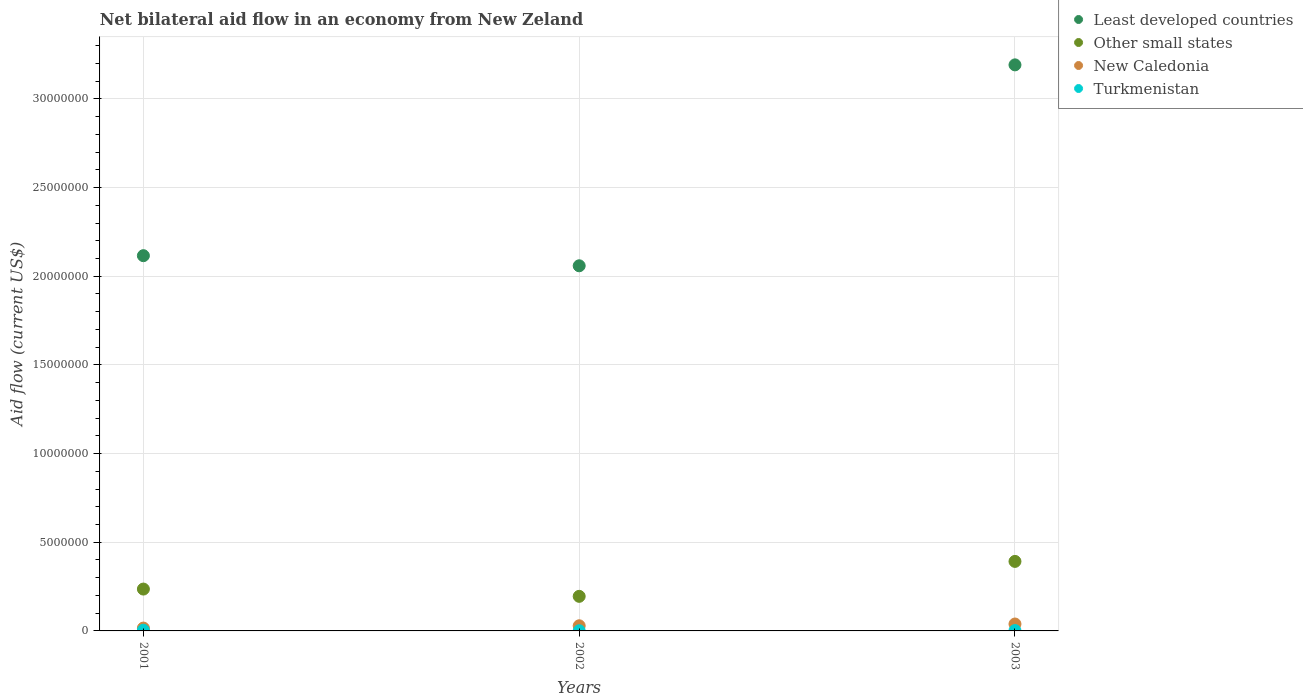How many different coloured dotlines are there?
Offer a terse response. 4. Across all years, what is the maximum net bilateral aid flow in Other small states?
Give a very brief answer. 3.92e+06. Across all years, what is the minimum net bilateral aid flow in Least developed countries?
Provide a succinct answer. 2.06e+07. In which year was the net bilateral aid flow in Least developed countries maximum?
Your answer should be very brief. 2003. What is the difference between the net bilateral aid flow in Turkmenistan in 2002 and that in 2003?
Your response must be concise. -10000. What is the difference between the net bilateral aid flow in Other small states in 2002 and the net bilateral aid flow in Turkmenistan in 2001?
Offer a terse response. 1.91e+06. What is the average net bilateral aid flow in Turkmenistan per year?
Provide a succinct answer. 2.33e+04. What is the ratio of the net bilateral aid flow in Other small states in 2002 to that in 2003?
Offer a very short reply. 0.5. What is the difference between the highest and the second highest net bilateral aid flow in Turkmenistan?
Your response must be concise. 2.00e+04. What is the difference between the highest and the lowest net bilateral aid flow in Other small states?
Make the answer very short. 1.97e+06. Is the sum of the net bilateral aid flow in Least developed countries in 2001 and 2002 greater than the maximum net bilateral aid flow in New Caledonia across all years?
Offer a terse response. Yes. Is the net bilateral aid flow in New Caledonia strictly greater than the net bilateral aid flow in Least developed countries over the years?
Provide a succinct answer. No. Are the values on the major ticks of Y-axis written in scientific E-notation?
Give a very brief answer. No. What is the title of the graph?
Your answer should be very brief. Net bilateral aid flow in an economy from New Zeland. Does "Burkina Faso" appear as one of the legend labels in the graph?
Your response must be concise. No. What is the label or title of the Y-axis?
Your answer should be very brief. Aid flow (current US$). What is the Aid flow (current US$) of Least developed countries in 2001?
Your answer should be compact. 2.12e+07. What is the Aid flow (current US$) in Other small states in 2001?
Provide a succinct answer. 2.36e+06. What is the Aid flow (current US$) of Least developed countries in 2002?
Keep it short and to the point. 2.06e+07. What is the Aid flow (current US$) in Other small states in 2002?
Provide a short and direct response. 1.95e+06. What is the Aid flow (current US$) of Turkmenistan in 2002?
Provide a succinct answer. 10000. What is the Aid flow (current US$) in Least developed countries in 2003?
Offer a terse response. 3.19e+07. What is the Aid flow (current US$) of Other small states in 2003?
Ensure brevity in your answer.  3.92e+06. What is the Aid flow (current US$) of New Caledonia in 2003?
Offer a terse response. 3.90e+05. What is the Aid flow (current US$) of Turkmenistan in 2003?
Offer a very short reply. 2.00e+04. Across all years, what is the maximum Aid flow (current US$) in Least developed countries?
Offer a very short reply. 3.19e+07. Across all years, what is the maximum Aid flow (current US$) of Other small states?
Your answer should be very brief. 3.92e+06. Across all years, what is the maximum Aid flow (current US$) of Turkmenistan?
Offer a terse response. 4.00e+04. Across all years, what is the minimum Aid flow (current US$) in Least developed countries?
Offer a terse response. 2.06e+07. Across all years, what is the minimum Aid flow (current US$) of Other small states?
Make the answer very short. 1.95e+06. Across all years, what is the minimum Aid flow (current US$) in Turkmenistan?
Ensure brevity in your answer.  10000. What is the total Aid flow (current US$) of Least developed countries in the graph?
Provide a succinct answer. 7.37e+07. What is the total Aid flow (current US$) in Other small states in the graph?
Keep it short and to the point. 8.23e+06. What is the total Aid flow (current US$) of New Caledonia in the graph?
Keep it short and to the point. 8.40e+05. What is the total Aid flow (current US$) of Turkmenistan in the graph?
Give a very brief answer. 7.00e+04. What is the difference between the Aid flow (current US$) of Least developed countries in 2001 and that in 2002?
Give a very brief answer. 5.70e+05. What is the difference between the Aid flow (current US$) of New Caledonia in 2001 and that in 2002?
Provide a short and direct response. -1.30e+05. What is the difference between the Aid flow (current US$) in Least developed countries in 2001 and that in 2003?
Make the answer very short. -1.08e+07. What is the difference between the Aid flow (current US$) of Other small states in 2001 and that in 2003?
Your answer should be compact. -1.56e+06. What is the difference between the Aid flow (current US$) in Least developed countries in 2002 and that in 2003?
Make the answer very short. -1.13e+07. What is the difference between the Aid flow (current US$) in Other small states in 2002 and that in 2003?
Ensure brevity in your answer.  -1.97e+06. What is the difference between the Aid flow (current US$) in New Caledonia in 2002 and that in 2003?
Your response must be concise. -1.00e+05. What is the difference between the Aid flow (current US$) of Least developed countries in 2001 and the Aid flow (current US$) of Other small states in 2002?
Offer a terse response. 1.92e+07. What is the difference between the Aid flow (current US$) of Least developed countries in 2001 and the Aid flow (current US$) of New Caledonia in 2002?
Offer a terse response. 2.09e+07. What is the difference between the Aid flow (current US$) in Least developed countries in 2001 and the Aid flow (current US$) in Turkmenistan in 2002?
Your response must be concise. 2.12e+07. What is the difference between the Aid flow (current US$) in Other small states in 2001 and the Aid flow (current US$) in New Caledonia in 2002?
Provide a short and direct response. 2.07e+06. What is the difference between the Aid flow (current US$) in Other small states in 2001 and the Aid flow (current US$) in Turkmenistan in 2002?
Ensure brevity in your answer.  2.35e+06. What is the difference between the Aid flow (current US$) in New Caledonia in 2001 and the Aid flow (current US$) in Turkmenistan in 2002?
Provide a succinct answer. 1.50e+05. What is the difference between the Aid flow (current US$) in Least developed countries in 2001 and the Aid flow (current US$) in Other small states in 2003?
Keep it short and to the point. 1.72e+07. What is the difference between the Aid flow (current US$) of Least developed countries in 2001 and the Aid flow (current US$) of New Caledonia in 2003?
Offer a very short reply. 2.08e+07. What is the difference between the Aid flow (current US$) of Least developed countries in 2001 and the Aid flow (current US$) of Turkmenistan in 2003?
Ensure brevity in your answer.  2.11e+07. What is the difference between the Aid flow (current US$) of Other small states in 2001 and the Aid flow (current US$) of New Caledonia in 2003?
Your answer should be compact. 1.97e+06. What is the difference between the Aid flow (current US$) of Other small states in 2001 and the Aid flow (current US$) of Turkmenistan in 2003?
Offer a terse response. 2.34e+06. What is the difference between the Aid flow (current US$) of New Caledonia in 2001 and the Aid flow (current US$) of Turkmenistan in 2003?
Keep it short and to the point. 1.40e+05. What is the difference between the Aid flow (current US$) of Least developed countries in 2002 and the Aid flow (current US$) of Other small states in 2003?
Your answer should be very brief. 1.67e+07. What is the difference between the Aid flow (current US$) in Least developed countries in 2002 and the Aid flow (current US$) in New Caledonia in 2003?
Ensure brevity in your answer.  2.02e+07. What is the difference between the Aid flow (current US$) in Least developed countries in 2002 and the Aid flow (current US$) in Turkmenistan in 2003?
Your answer should be very brief. 2.06e+07. What is the difference between the Aid flow (current US$) in Other small states in 2002 and the Aid flow (current US$) in New Caledonia in 2003?
Ensure brevity in your answer.  1.56e+06. What is the difference between the Aid flow (current US$) in Other small states in 2002 and the Aid flow (current US$) in Turkmenistan in 2003?
Make the answer very short. 1.93e+06. What is the average Aid flow (current US$) of Least developed countries per year?
Ensure brevity in your answer.  2.46e+07. What is the average Aid flow (current US$) in Other small states per year?
Provide a succinct answer. 2.74e+06. What is the average Aid flow (current US$) of Turkmenistan per year?
Offer a terse response. 2.33e+04. In the year 2001, what is the difference between the Aid flow (current US$) in Least developed countries and Aid flow (current US$) in Other small states?
Your answer should be very brief. 1.88e+07. In the year 2001, what is the difference between the Aid flow (current US$) in Least developed countries and Aid flow (current US$) in New Caledonia?
Give a very brief answer. 2.10e+07. In the year 2001, what is the difference between the Aid flow (current US$) of Least developed countries and Aid flow (current US$) of Turkmenistan?
Your answer should be very brief. 2.11e+07. In the year 2001, what is the difference between the Aid flow (current US$) in Other small states and Aid flow (current US$) in New Caledonia?
Ensure brevity in your answer.  2.20e+06. In the year 2001, what is the difference between the Aid flow (current US$) of Other small states and Aid flow (current US$) of Turkmenistan?
Make the answer very short. 2.32e+06. In the year 2001, what is the difference between the Aid flow (current US$) in New Caledonia and Aid flow (current US$) in Turkmenistan?
Offer a very short reply. 1.20e+05. In the year 2002, what is the difference between the Aid flow (current US$) in Least developed countries and Aid flow (current US$) in Other small states?
Offer a very short reply. 1.86e+07. In the year 2002, what is the difference between the Aid flow (current US$) of Least developed countries and Aid flow (current US$) of New Caledonia?
Provide a succinct answer. 2.03e+07. In the year 2002, what is the difference between the Aid flow (current US$) of Least developed countries and Aid flow (current US$) of Turkmenistan?
Your answer should be compact. 2.06e+07. In the year 2002, what is the difference between the Aid flow (current US$) of Other small states and Aid flow (current US$) of New Caledonia?
Your response must be concise. 1.66e+06. In the year 2002, what is the difference between the Aid flow (current US$) of Other small states and Aid flow (current US$) of Turkmenistan?
Provide a succinct answer. 1.94e+06. In the year 2003, what is the difference between the Aid flow (current US$) in Least developed countries and Aid flow (current US$) in Other small states?
Offer a terse response. 2.80e+07. In the year 2003, what is the difference between the Aid flow (current US$) in Least developed countries and Aid flow (current US$) in New Caledonia?
Keep it short and to the point. 3.15e+07. In the year 2003, what is the difference between the Aid flow (current US$) of Least developed countries and Aid flow (current US$) of Turkmenistan?
Make the answer very short. 3.19e+07. In the year 2003, what is the difference between the Aid flow (current US$) of Other small states and Aid flow (current US$) of New Caledonia?
Provide a succinct answer. 3.53e+06. In the year 2003, what is the difference between the Aid flow (current US$) of Other small states and Aid flow (current US$) of Turkmenistan?
Offer a terse response. 3.90e+06. What is the ratio of the Aid flow (current US$) of Least developed countries in 2001 to that in 2002?
Keep it short and to the point. 1.03. What is the ratio of the Aid flow (current US$) in Other small states in 2001 to that in 2002?
Ensure brevity in your answer.  1.21. What is the ratio of the Aid flow (current US$) in New Caledonia in 2001 to that in 2002?
Your answer should be compact. 0.55. What is the ratio of the Aid flow (current US$) in Turkmenistan in 2001 to that in 2002?
Ensure brevity in your answer.  4. What is the ratio of the Aid flow (current US$) of Least developed countries in 2001 to that in 2003?
Provide a short and direct response. 0.66. What is the ratio of the Aid flow (current US$) of Other small states in 2001 to that in 2003?
Give a very brief answer. 0.6. What is the ratio of the Aid flow (current US$) of New Caledonia in 2001 to that in 2003?
Make the answer very short. 0.41. What is the ratio of the Aid flow (current US$) of Turkmenistan in 2001 to that in 2003?
Give a very brief answer. 2. What is the ratio of the Aid flow (current US$) of Least developed countries in 2002 to that in 2003?
Give a very brief answer. 0.65. What is the ratio of the Aid flow (current US$) of Other small states in 2002 to that in 2003?
Ensure brevity in your answer.  0.5. What is the ratio of the Aid flow (current US$) of New Caledonia in 2002 to that in 2003?
Make the answer very short. 0.74. What is the ratio of the Aid flow (current US$) of Turkmenistan in 2002 to that in 2003?
Provide a succinct answer. 0.5. What is the difference between the highest and the second highest Aid flow (current US$) in Least developed countries?
Offer a terse response. 1.08e+07. What is the difference between the highest and the second highest Aid flow (current US$) in Other small states?
Make the answer very short. 1.56e+06. What is the difference between the highest and the second highest Aid flow (current US$) in New Caledonia?
Offer a very short reply. 1.00e+05. What is the difference between the highest and the lowest Aid flow (current US$) of Least developed countries?
Offer a very short reply. 1.13e+07. What is the difference between the highest and the lowest Aid flow (current US$) in Other small states?
Ensure brevity in your answer.  1.97e+06. What is the difference between the highest and the lowest Aid flow (current US$) of New Caledonia?
Give a very brief answer. 2.30e+05. What is the difference between the highest and the lowest Aid flow (current US$) in Turkmenistan?
Offer a very short reply. 3.00e+04. 